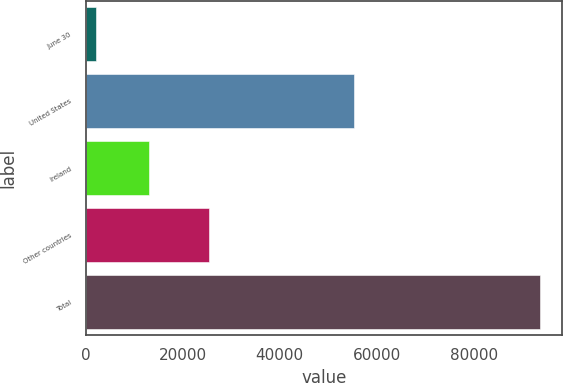<chart> <loc_0><loc_0><loc_500><loc_500><bar_chart><fcel>June 30<fcel>United States<fcel>Ireland<fcel>Other countries<fcel>Total<nl><fcel>2019<fcel>55252<fcel>12958<fcel>25422<fcel>93632<nl></chart> 